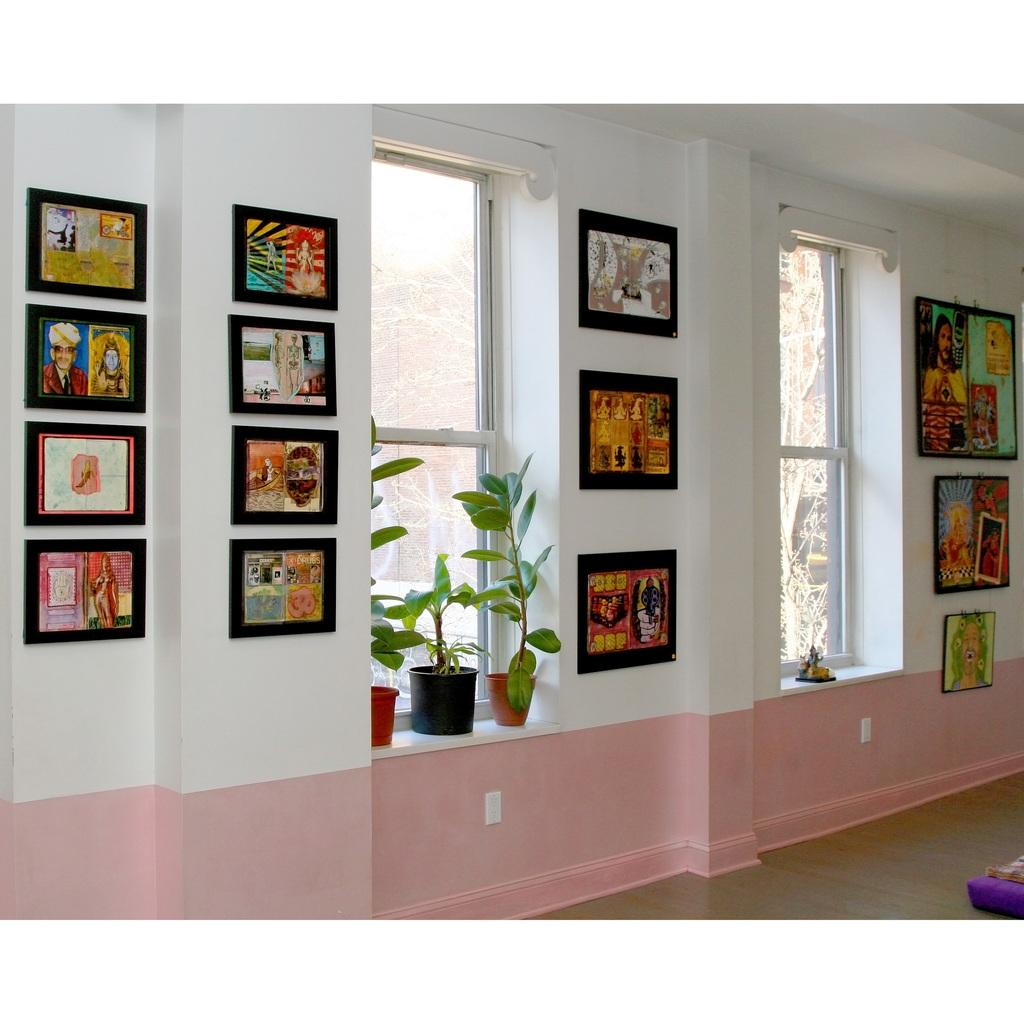What is hanging on the wall in the image? There are photo frames on the wall in the image. What type of greenery is present in the image? There are house plants in the image. How many windows can be seen in the image? There are two windows in the image. What type of seed is being planted in the plantation shown in the image? There is no plantation or seed present in the image; it features photo frames on the wall and house plants. Is there a glove visible in the image? No, there is no glove present in the image. 